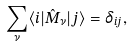Convert formula to latex. <formula><loc_0><loc_0><loc_500><loc_500>\sum _ { \nu } \langle i | \hat { M } _ { \nu } | j \rangle = \delta _ { i j } ,</formula> 